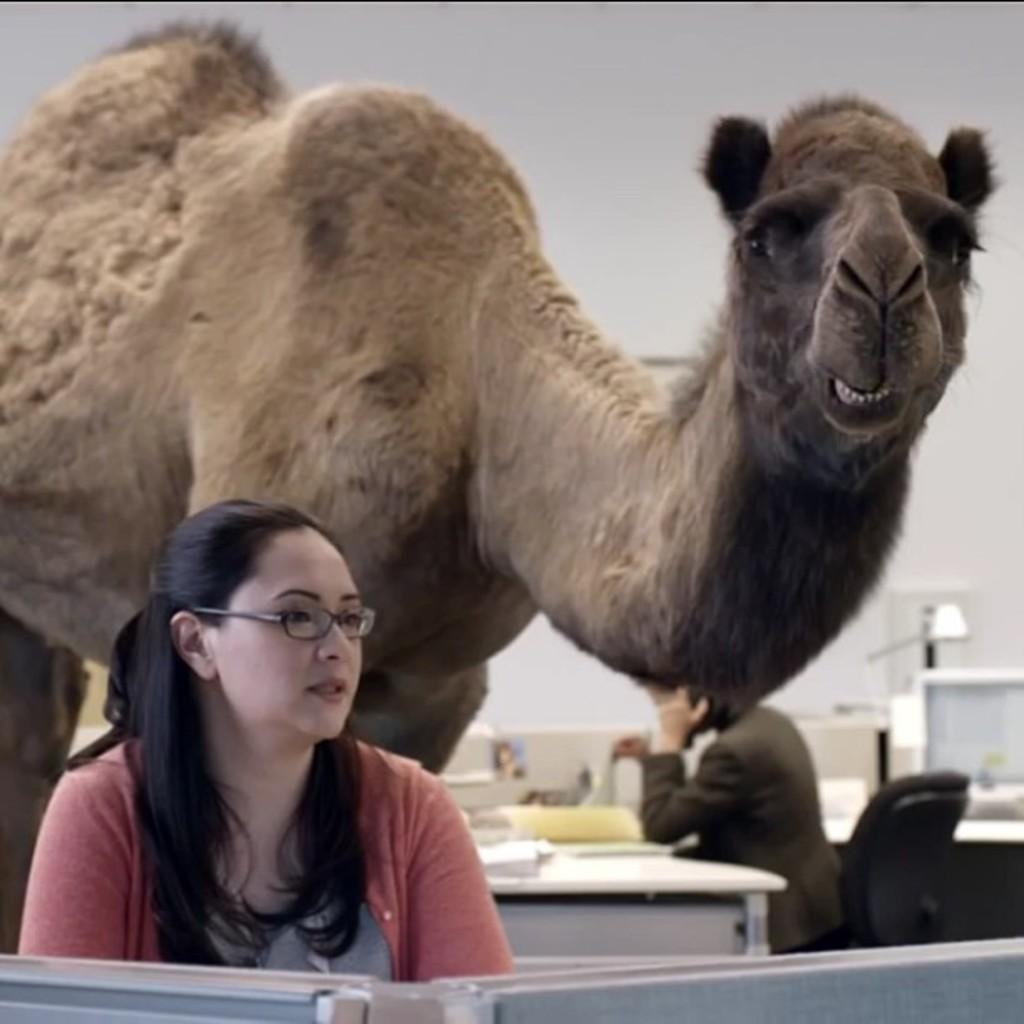Who is present in the image? There is a woman in the image. What is the woman doing in the image? There is a person sitting on a chair in the image, and it is likely the woman who is sitting. What can be seen in the background of the image? In the background of the image, there is a camel, a table, a wall, and other objects. Can you describe the setting of the image? The image appears to be set in a room or an outdoor area with a camel and other objects in the background. What type of sign can be seen in the image? There is no sign present in the image; it features a woman sitting on a chair with a camel and other objects in the background. 